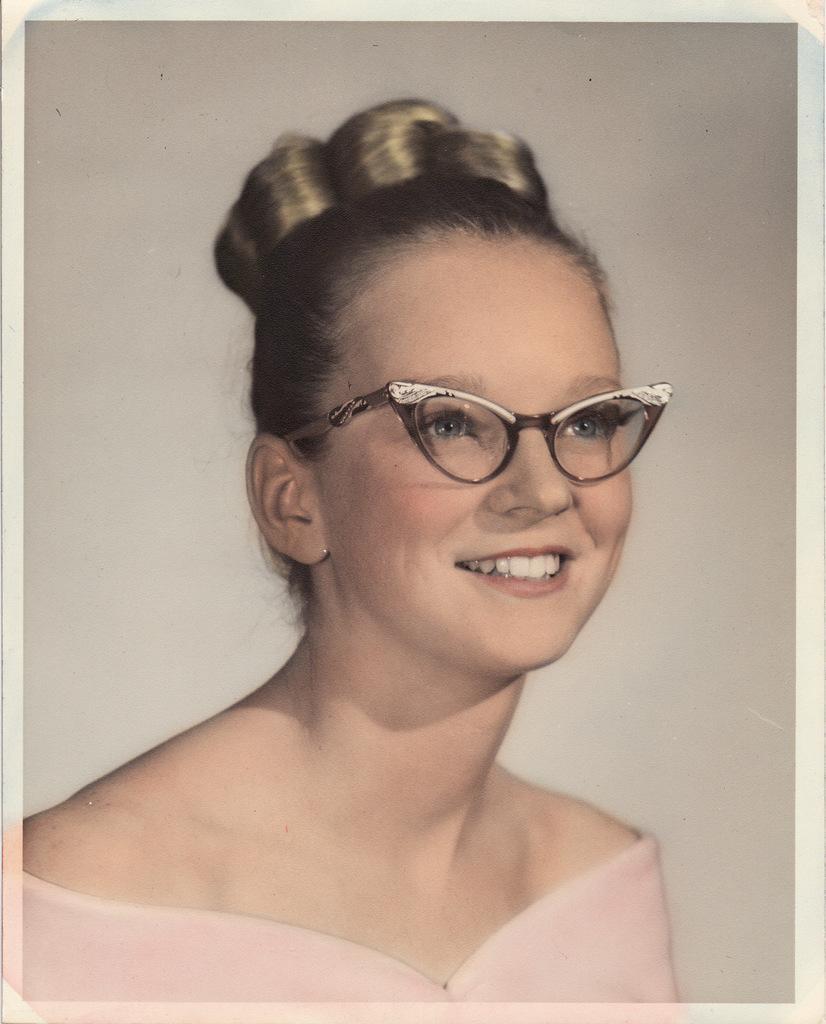Describe this image in one or two sentences. In this picture, we can see a woman is smiling and behind the woman there is a wall. 